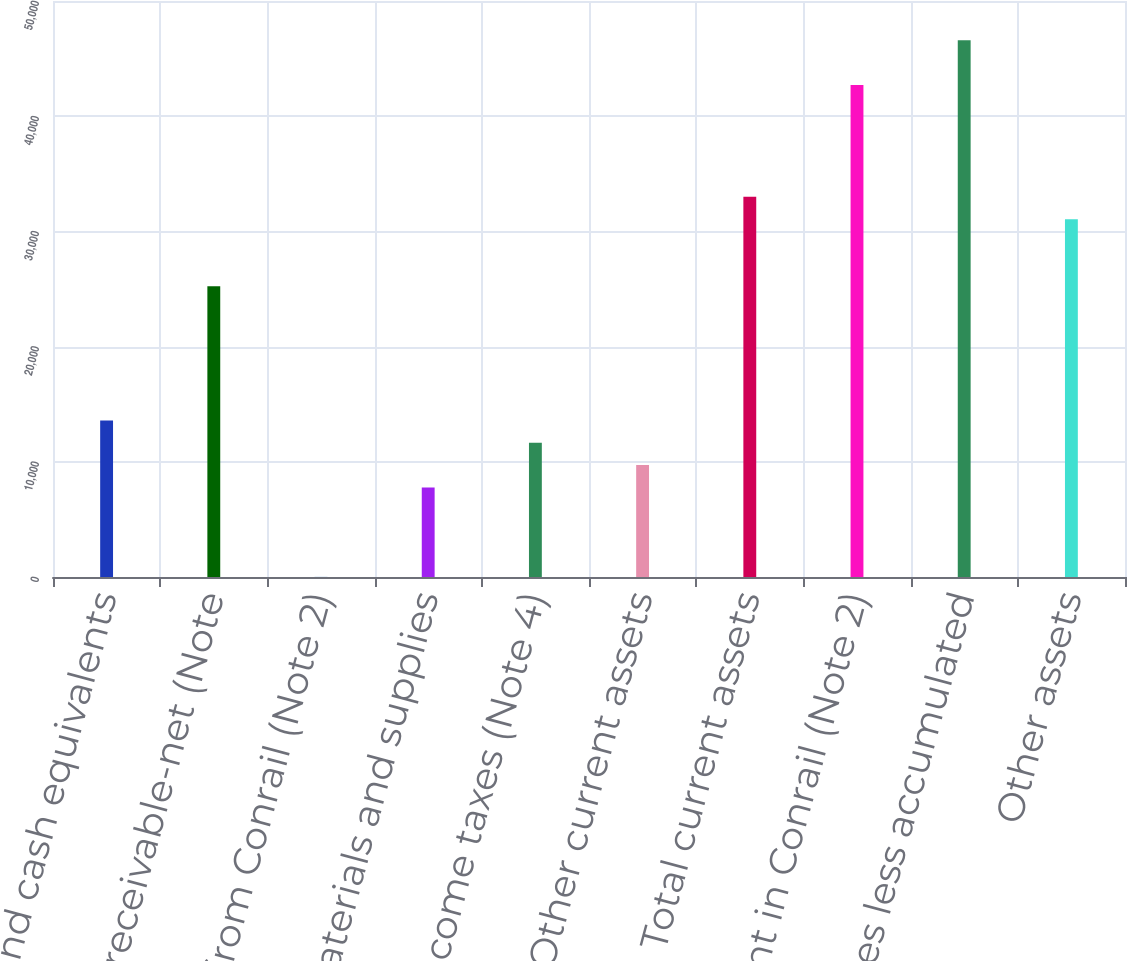Convert chart to OTSL. <chart><loc_0><loc_0><loc_500><loc_500><bar_chart><fcel>Cash and cash equivalents<fcel>Accounts receivable-net (Note<fcel>Due from Conrail (Note 2)<fcel>Materials and supplies<fcel>Deferred income taxes (Note 4)<fcel>Other current assets<fcel>Total current assets<fcel>Investment in Conrail (Note 2)<fcel>Properties less accumulated<fcel>Other assets<nl><fcel>13595<fcel>25241<fcel>8<fcel>7772<fcel>11654<fcel>9713<fcel>33005<fcel>42710<fcel>46592<fcel>31064<nl></chart> 